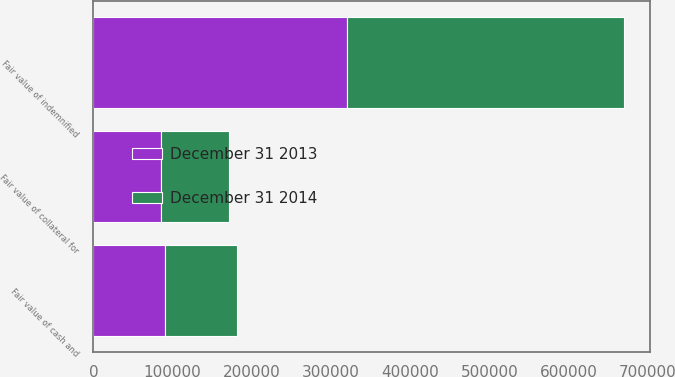Convert chart. <chart><loc_0><loc_0><loc_500><loc_500><stacked_bar_chart><ecel><fcel>Fair value of indemnified<fcel>Fair value of cash and<fcel>Fair value of collateral for<nl><fcel>December 31 2014<fcel>349766<fcel>90819<fcel>85309<nl><fcel>December 31 2013<fcel>320078<fcel>91097<fcel>85374<nl></chart> 